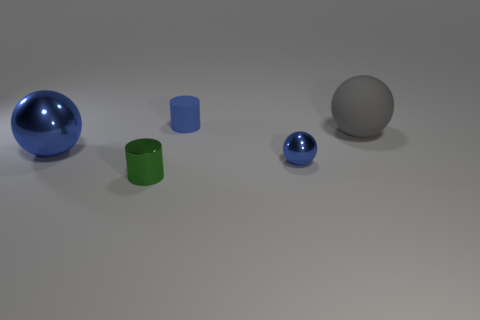How many blue spheres must be subtracted to get 1 blue spheres? 1 Subtract all small blue metal spheres. How many spheres are left? 2 Subtract all blue spheres. How many spheres are left? 1 Add 2 rubber balls. How many objects exist? 7 Subtract 3 balls. How many balls are left? 0 Subtract all yellow cylinders. Subtract all yellow blocks. How many cylinders are left? 2 Subtract all gray cubes. How many purple cylinders are left? 0 Subtract all tiny blue objects. Subtract all large blue objects. How many objects are left? 2 Add 1 large shiny things. How many large shiny things are left? 2 Add 5 tiny metal things. How many tiny metal things exist? 7 